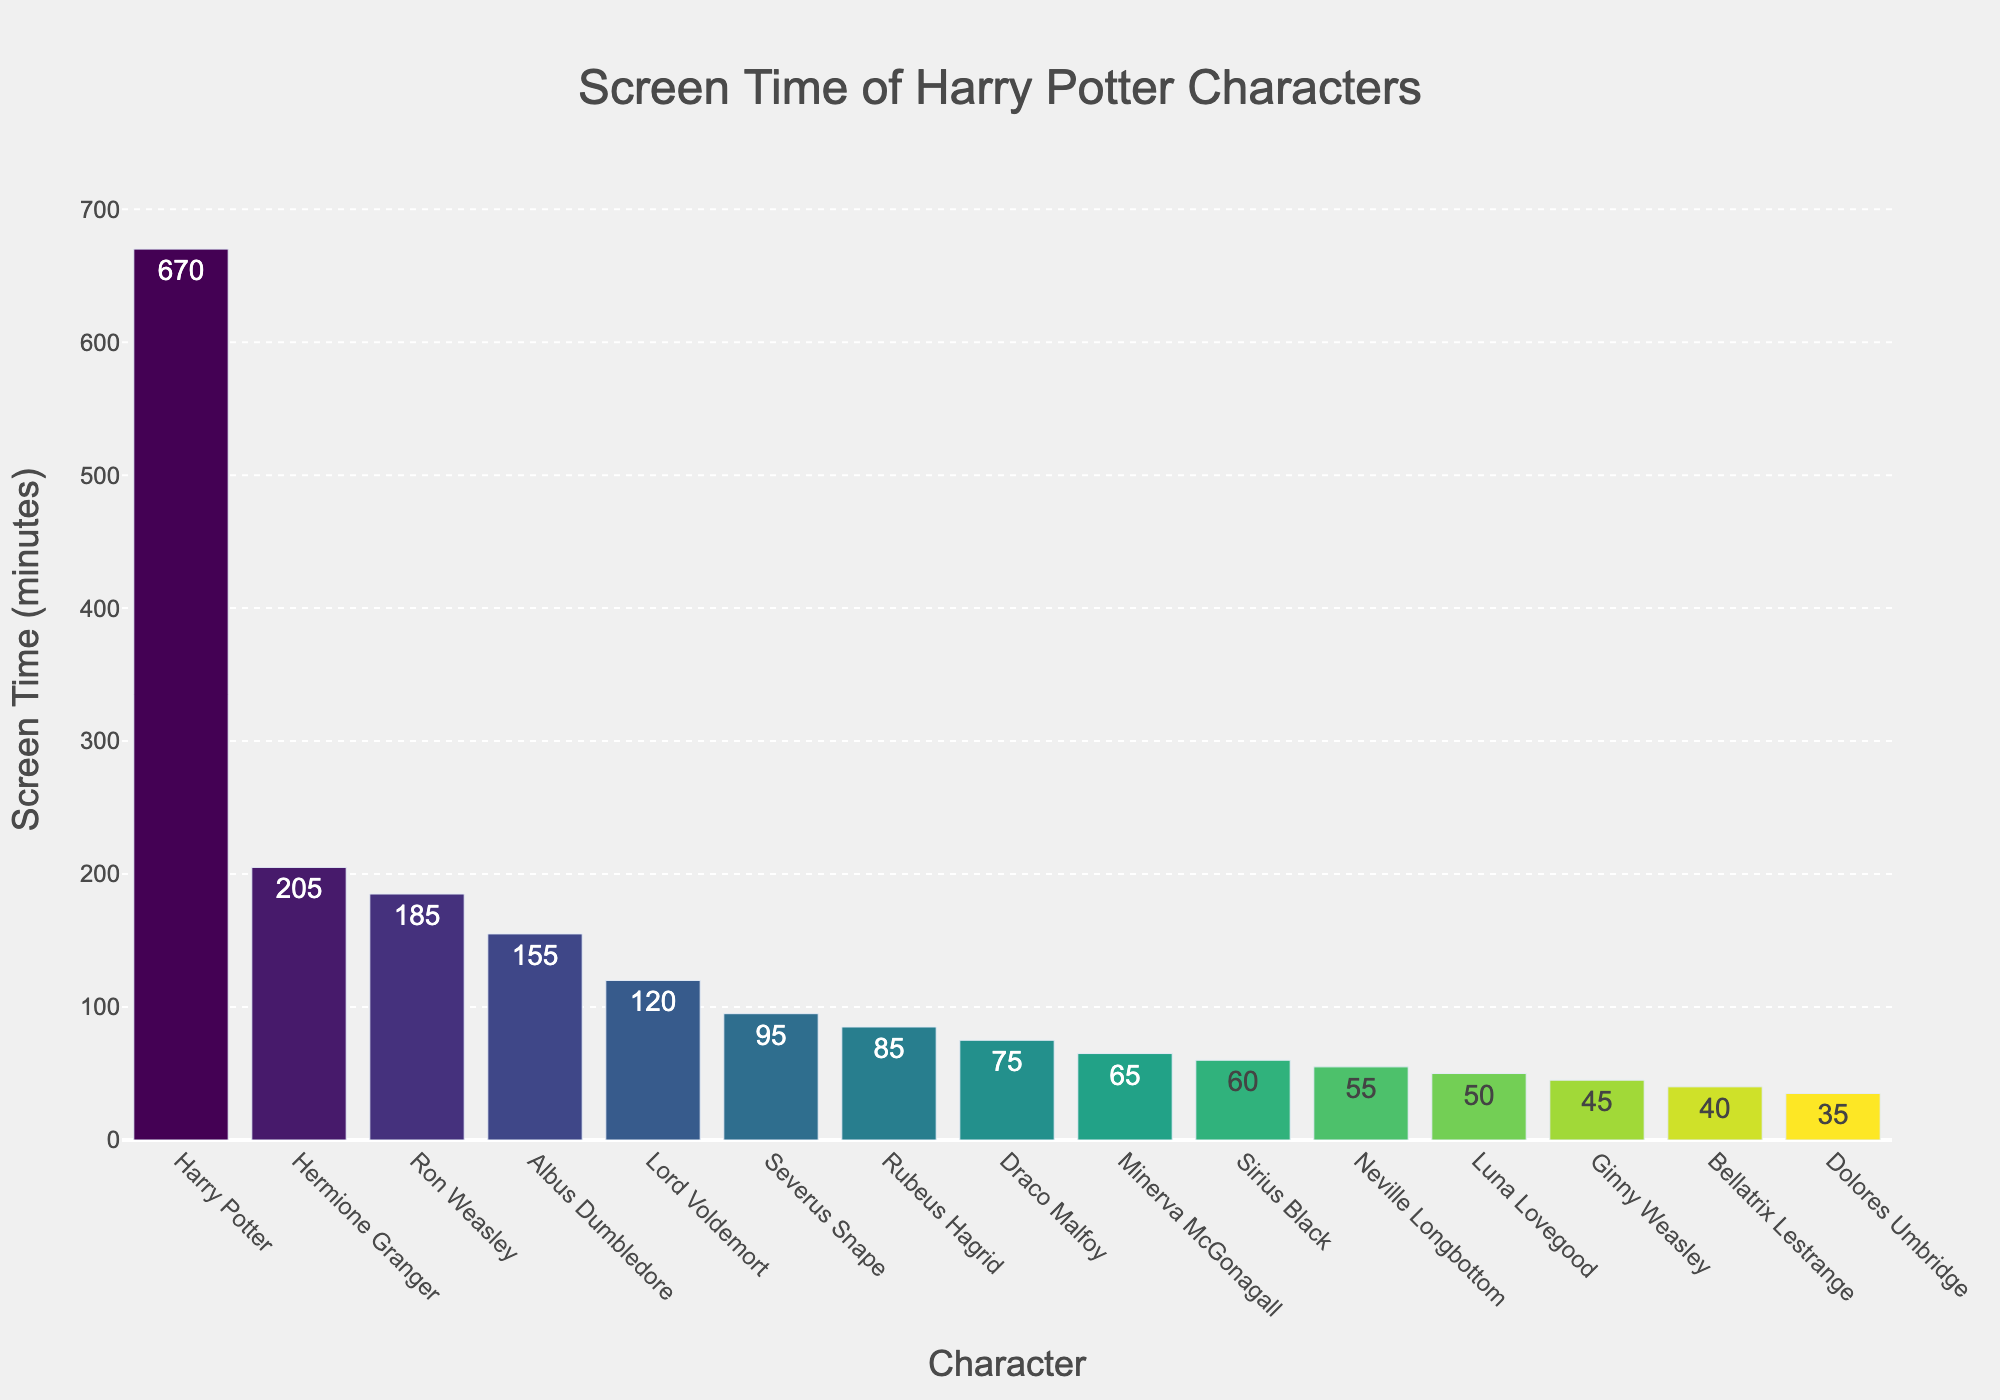Which character has the most screen time? By looking at the heights of the bars in the figure, we can see that Harry Potter's bar is the tallest and therefore represents the character with the most screen time.
Answer: Harry Potter How much more screen time does Hermione have compared to Ron? Hermione has 205 minutes of screen time and Ron has 185 minutes. The difference can be calculated by subtracting Ron’s screen time from Hermione’s (205 - 185).
Answer: 20 minutes Which characters have a screen time of less than 100 minutes? By examining the bars with heights representing screen times less than 100 minutes, we find Severus Snape (95), Rubeus Hagrid (85), Draco Malfoy (75), Minerva McGonagall (65), Sirius Black (60), Neville Longbottom (55), Luna Lovegood (50), Ginny Weasley (45), Bellatrix Lestrange (40), Dolores Umbridge (35).
Answer: Severus Snape, Rubeus Hagrid, Draco Malfoy, Minerva McGonagall, Sirius Black, Neville Longbottom, Luna Lovegood, Ginny Weasley, Bellatrix Lestrange, Dolores Umbridge What is the total screen time of all the characters combined? Summing up the screen times of all characters: 670 (Harry) + 205 (Hermione) + 185 (Ron) + 155 (Dumbledore) + 120 (Voldemort) + 95 (Snape) + 85 (Hagrid) + 75 (Draco) + 65 (McGonagall) + 60 (Sirius) + 55 (Neville) + 50 (Luna) + 45 (Ginny) + 40 (Bellatrix) + 35 (Umbridge).
Answer: 1945 minutes What is the average screen time of the top 3 characters? Adding the screen times of the top 3 characters (Harry: 670, Hermione: 205, Ron: 185) and dividing by 3 to get the average: (670 + 205 + 185) / 3.
Answer: 353.33 minutes Who has more screen time, Albus Dumbledore or Lord Voldemort, and by how much? Albus Dumbledore has 155 minutes of screen time and Lord Voldemort has 120 minutes. Subtract Voldemort’s screen time from Dumbledore’s (155 - 120).
Answer: Albus Dumbledore by 35 minutes List the characters with screen time between 50 and 100 minutes? Visual observation of the bars falling between the heights that represent screen times between 50 and 100 minutes: Severus Snape (95), Rubeus Hagrid (85), Draco Malfoy (75), Minerva McGonagall (65), Sirius Black (60), Neville Longbottom (55), Luna Lovegood (50).
Answer: Severus Snape, Rubeus Hagrid, Draco Malfoy, Minerva McGonagall, Sirius Black, Neville Longbottom, Luna Lovegood Who are the characters with less screen time than Draco Malfoy? By observing all bars that are shorter than Draco Malfoy’s (75 minutes), we find Minerva McGonagall (65), Sirius Black (60), Neville Longbottom (55), Luna Lovegood (50), Ginny Weasley (45), Bellatrix Lestrange (40), Dolores Umbridge (35).
Answer: Minerva McGonagall, Sirius Black, Neville Longbottom, Luna Lovegood, Ginny Weasley, Bellatrix Lestrange, Dolores Umbridge 